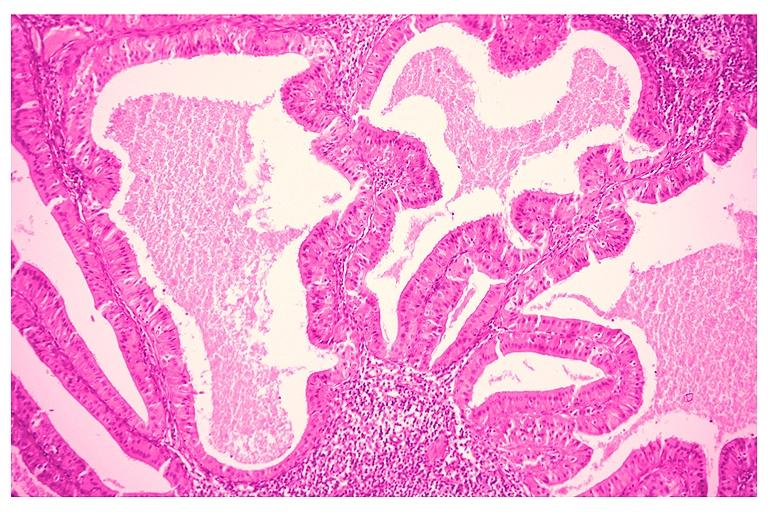s quite good liver present?
Answer the question using a single word or phrase. No 